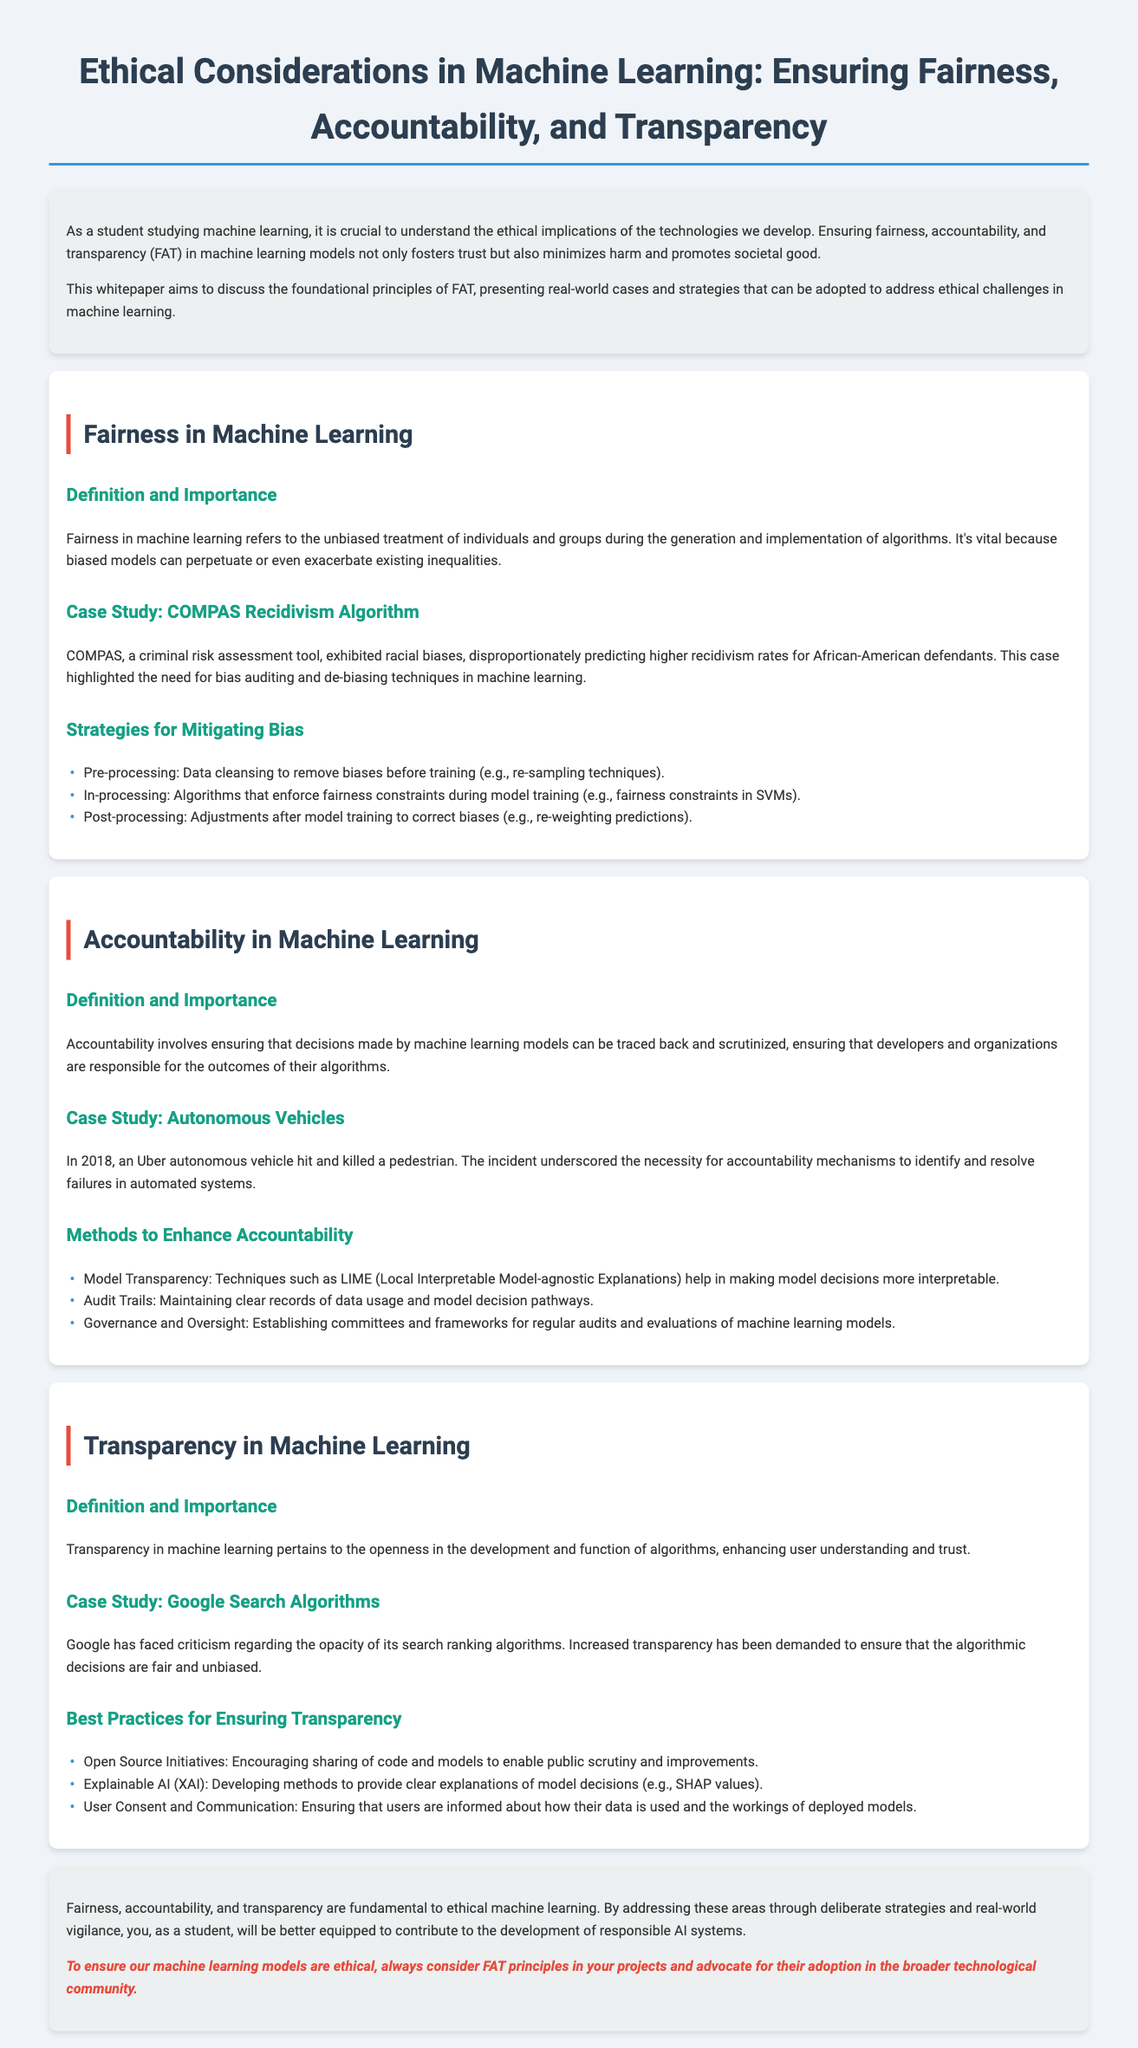What are the three fundamental principles discussed in the whitepaper? The whitepaper highlights fairness, accountability, and transparency as the three fundamental principles in machine learning ethics.
Answer: fairness, accountability, transparency What algorithmic tool is mentioned in the context of bias auditing? The COMPAS recidivism algorithm is used as a case study highlighting the need for bias auditing and de-biasing techniques.
Answer: COMPAS In what year did the Uber autonomous vehicle incident occur? The document discusses the incident of an Uber autonomous vehicle hitting and killing a pedestrian in 2018, underscoring accountability needs.
Answer: 2018 What does XAI stand for as mentioned in the transparency section? In the best practices for ensuring transparency, the acronym XAI refers to Explainable AI.
Answer: Explainable AI What is one pre-processing strategy to mitigate bias? Data cleansing to remove biases before training is one of the pre-processing strategies mentioned for mitigating bias.
Answer: Data cleansing What case study illustrates the need for transparency in algorithms? The whitepaper references Google search algorithms as a case study illustrating the demand for increased transparency.
Answer: Google search algorithms What does the abbreviation FAT stand for in the context of this document? FAT stands for fairness, accountability, and transparency, which are key ethical principles addressed.
Answer: fairness, accountability, transparency What is one method to enhance accountability mentioned in the document? One method to enhance accountability is the use of audit trails that maintain clear records of data usage and model decision pathways.
Answer: Audit trails 